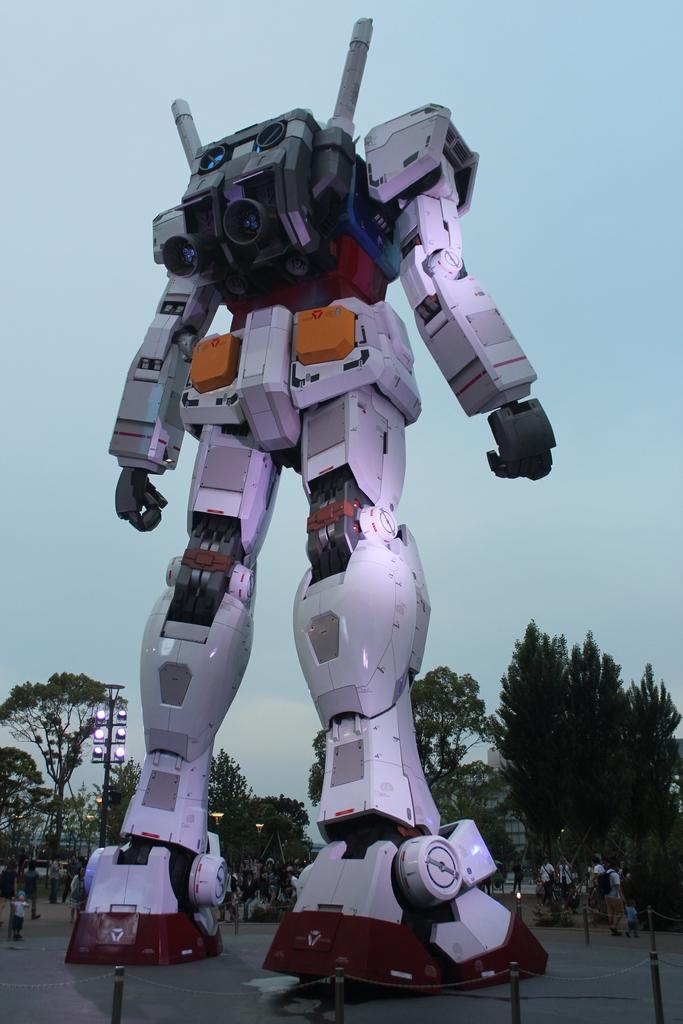What is the main subject in the image? There is a big robot in the image. What can be seen behind the robot? There are trees, humans, and poles behind the robot. What is visible at the top of the image? The sky is visible at the top of the image. What type of vessel is being used by the robot to exercise its muscles in the image? There is no vessel or exercise equipment present in the image, and the robot is not shown engaging in any physical activity. 